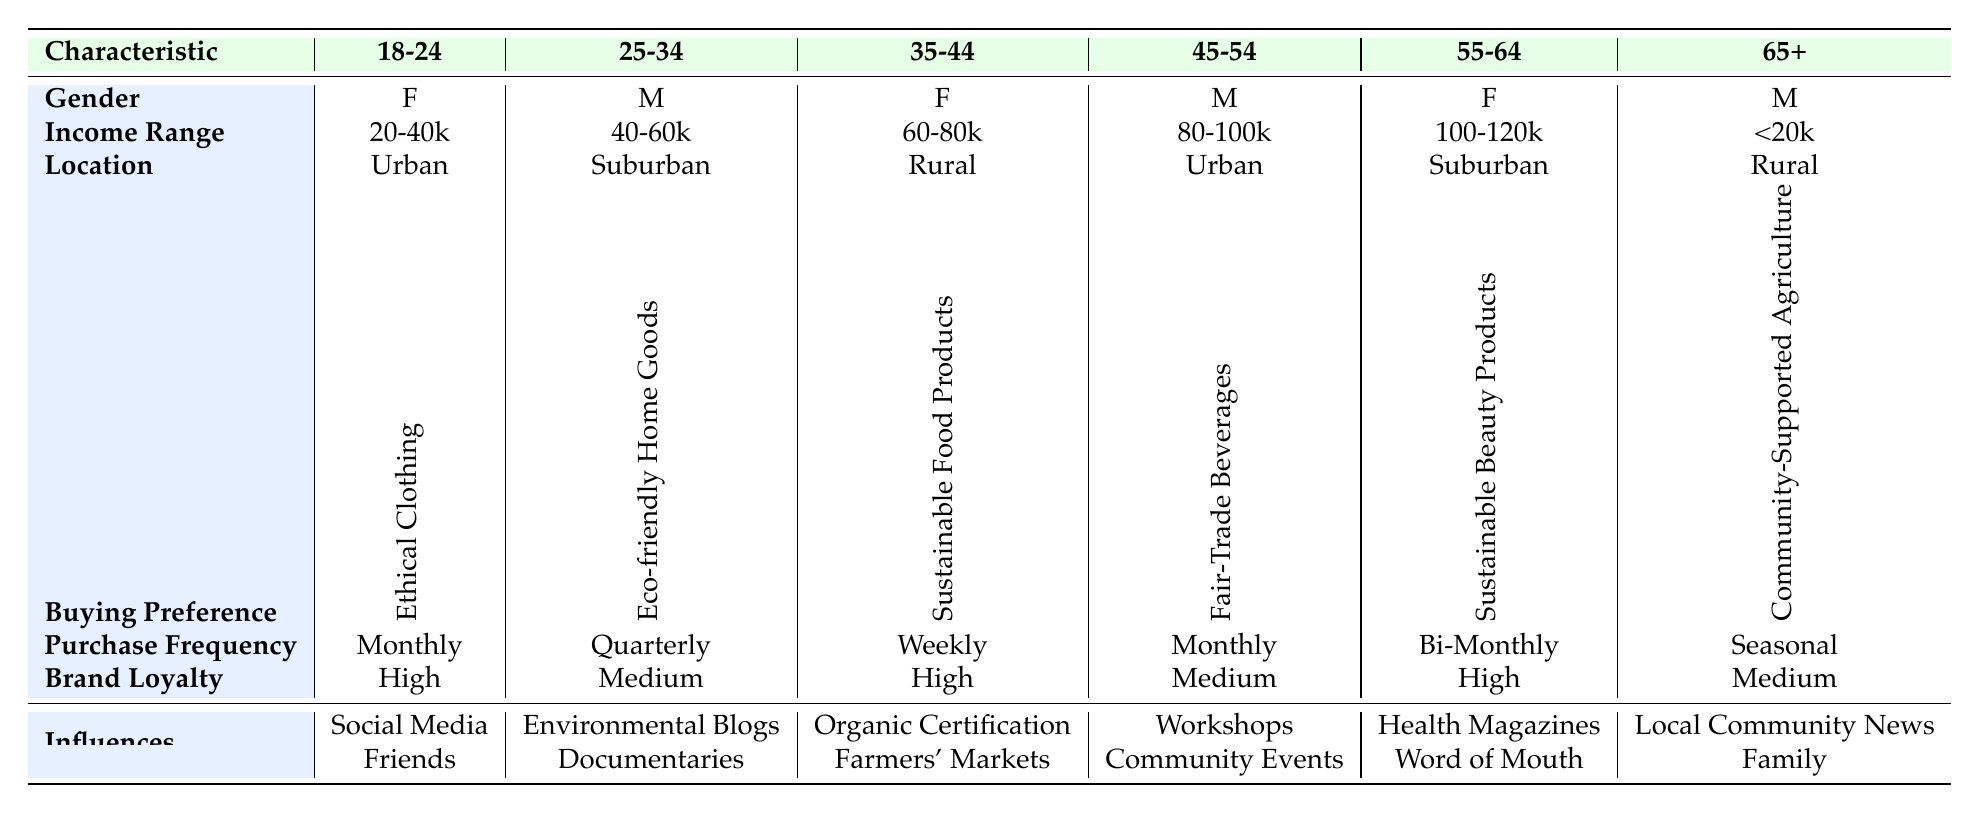What is the buying preference of customers aged 35-44? The table shows that the buying preference for the 35-44 age group is "Sustainable Food Products."
Answer: Sustainable Food Products How often do customers aged 55-64 purchase sustainable products? According to the table, customers aged 55-64 have a purchase frequency of "Bi-Monthly."
Answer: Bi-Monthly Which age group shows the highest brand loyalty? The table indicates that the 18-24, 35-44, and 55-64 age groups all have "High" brand loyalty.
Answer: 18-24, 35-44, and 55-64 Do all customers aged 65 and older prefer community-supported agriculture? Yes, the table specifies that customers 65 and older have a buying preference for "Community-Supported Agriculture (CSA)."
Answer: Yes What is the income range of the 25-34 age group? The income range listed for the 25-34 age group is "40,000-60,000."
Answer: 40,000-60,000 Which location is most common among customers aged 45-54? The table states that customers aged 45-54 predominantly reside in "Urban" areas.
Answer: Urban How many age groups have a purchase frequency of monthly? There are two age groups listed with a monthly purchase frequency: 18-24 and 45-54.
Answer: 2 Is the predominant gender for customers aged 55-64 female? Yes, the table shows that the gender for customers aged 55-64 is "Female."
Answer: Yes What influences purchasing decisions for customers aged 25-34? The influences listed for customers aged 25-34 include "Environmental Blogs" and "Documentaries."
Answer: Environmental Blogs and Documentaries What is the difference in income range between the 18-24 and 65+ age groups? The income range for 18-24 is "20,000-40,000," and for 65+, it's "Less than 20,000." This indicates a difference of at least 20,000, as 65+ earns less than the minimum of 18-24.
Answer: At least 20,000 Which age group has the highest purchase frequency? The highest purchase frequency listed is "Weekly," which belongs to the 35-44 age group.
Answer: 35-44 How many influences are noted for customers aged 18-24? The table contains two influences for customers aged 18-24: "Social Media" and "Friends."
Answer: 2 